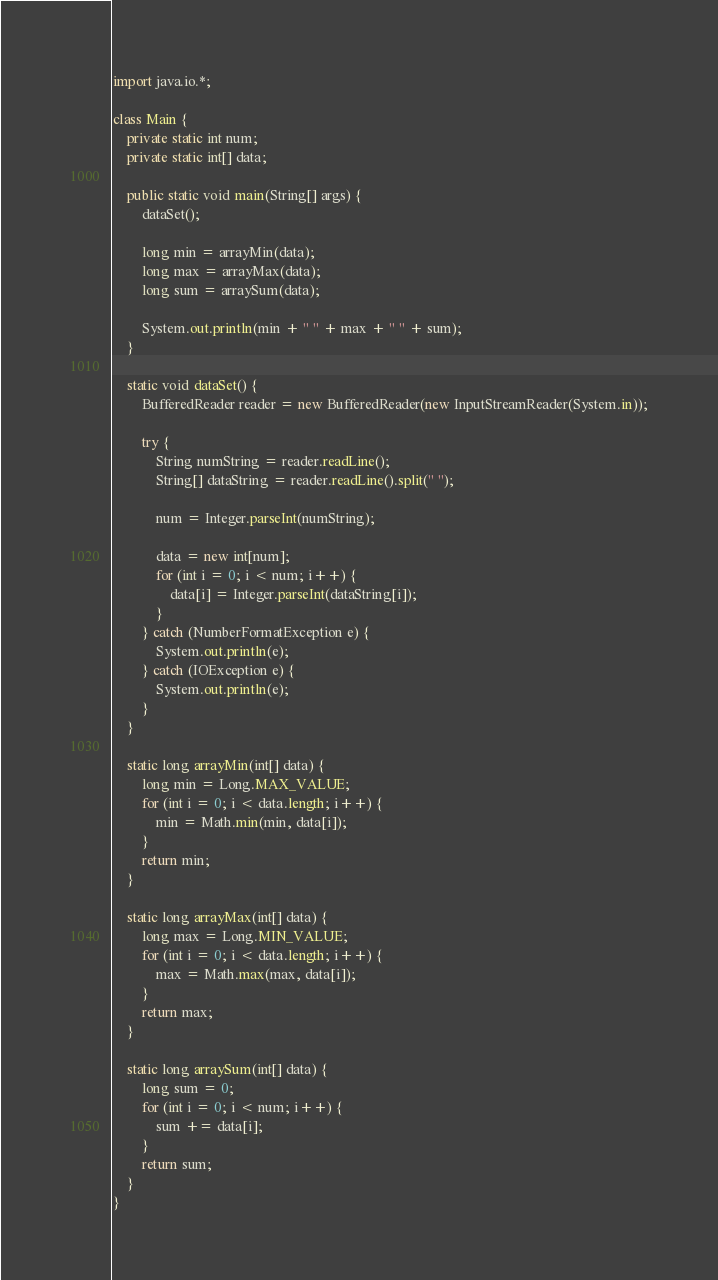<code> <loc_0><loc_0><loc_500><loc_500><_Java_>import java.io.*;

class Main {
    private static int num;
    private static int[] data;

    public static void main(String[] args) {
        dataSet();

        long min = arrayMin(data);
        long max = arrayMax(data);
        long sum = arraySum(data);

        System.out.println(min + " " + max + " " + sum);
    }

    static void dataSet() {
        BufferedReader reader = new BufferedReader(new InputStreamReader(System.in));

        try {
            String numString = reader.readLine();
            String[] dataString = reader.readLine().split(" ");

            num = Integer.parseInt(numString);

            data = new int[num];
            for (int i = 0; i < num; i++) {
                data[i] = Integer.parseInt(dataString[i]);
            }
        } catch (NumberFormatException e) {
            System.out.println(e);
        } catch (IOException e) {
            System.out.println(e);
        }
    }

    static long arrayMin(int[] data) {
        long min = Long.MAX_VALUE;
        for (int i = 0; i < data.length; i++) {
            min = Math.min(min, data[i]);
        }
        return min;
    }

    static long arrayMax(int[] data) {
        long max = Long.MIN_VALUE;
        for (int i = 0; i < data.length; i++) {
            max = Math.max(max, data[i]);
        }
        return max;
    }

    static long arraySum(int[] data) {
        long sum = 0;
        for (int i = 0; i < num; i++) {
            sum += data[i];
        }
        return sum;
    }
}</code> 